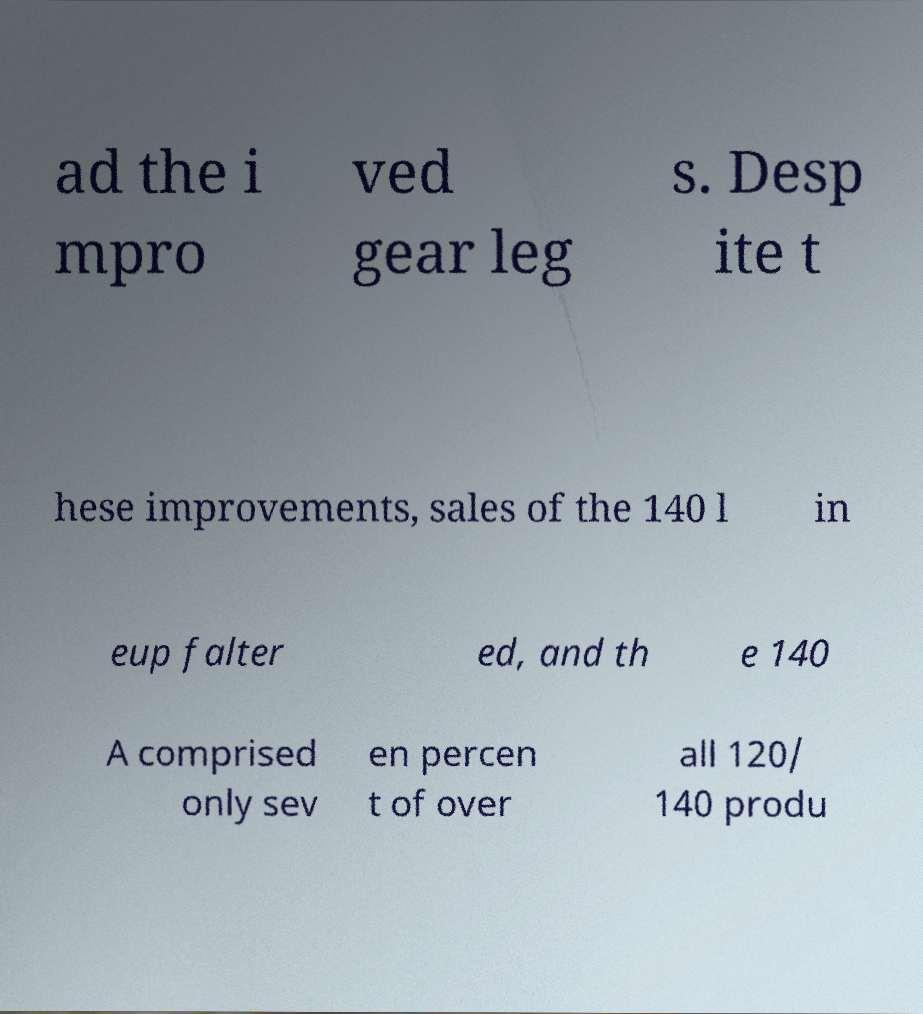Could you assist in decoding the text presented in this image and type it out clearly? ad the i mpro ved gear leg s. Desp ite t hese improvements, sales of the 140 l in eup falter ed, and th e 140 A comprised only sev en percen t of over all 120/ 140 produ 